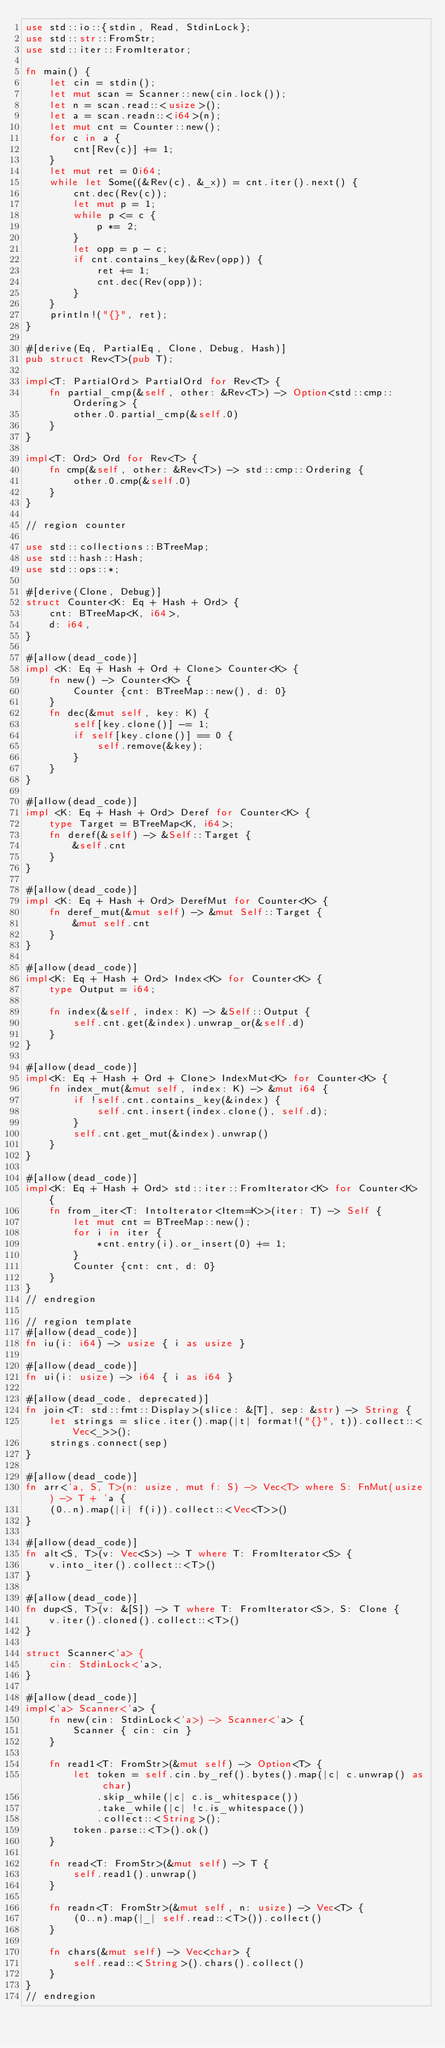Convert code to text. <code><loc_0><loc_0><loc_500><loc_500><_Rust_>use std::io::{stdin, Read, StdinLock};
use std::str::FromStr;
use std::iter::FromIterator;

fn main() {
    let cin = stdin();
    let mut scan = Scanner::new(cin.lock());
    let n = scan.read::<usize>();
    let a = scan.readn::<i64>(n);
    let mut cnt = Counter::new();
    for c in a {
        cnt[Rev(c)] += 1;
    }
    let mut ret = 0i64;
    while let Some((&Rev(c), &_x)) = cnt.iter().next() {
        cnt.dec(Rev(c));
        let mut p = 1;
        while p <= c {
            p *= 2;
        }
        let opp = p - c;
        if cnt.contains_key(&Rev(opp)) {
            ret += 1;
            cnt.dec(Rev(opp));
        }
    }
    println!("{}", ret);
}

#[derive(Eq, PartialEq, Clone, Debug, Hash)]
pub struct Rev<T>(pub T);

impl<T: PartialOrd> PartialOrd for Rev<T> {
    fn partial_cmp(&self, other: &Rev<T>) -> Option<std::cmp::Ordering> {
        other.0.partial_cmp(&self.0)
    }
}

impl<T: Ord> Ord for Rev<T> {
    fn cmp(&self, other: &Rev<T>) -> std::cmp::Ordering {
        other.0.cmp(&self.0)
    }
}

// region counter

use std::collections::BTreeMap;
use std::hash::Hash;
use std::ops::*;

#[derive(Clone, Debug)]
struct Counter<K: Eq + Hash + Ord> {
    cnt: BTreeMap<K, i64>,
    d: i64,
}

#[allow(dead_code)]
impl <K: Eq + Hash + Ord + Clone> Counter<K> {
    fn new() -> Counter<K> {
        Counter {cnt: BTreeMap::new(), d: 0}
    }
    fn dec(&mut self, key: K) {
        self[key.clone()] -= 1;
        if self[key.clone()] == 0 {
            self.remove(&key);
        }
    }
}

#[allow(dead_code)]
impl <K: Eq + Hash + Ord> Deref for Counter<K> {
    type Target = BTreeMap<K, i64>;
    fn deref(&self) -> &Self::Target {
        &self.cnt
    }
}

#[allow(dead_code)]
impl <K: Eq + Hash + Ord> DerefMut for Counter<K> {
    fn deref_mut(&mut self) -> &mut Self::Target {
        &mut self.cnt
    }
}

#[allow(dead_code)]
impl<K: Eq + Hash + Ord> Index<K> for Counter<K> {
    type Output = i64;

    fn index(&self, index: K) -> &Self::Output {
        self.cnt.get(&index).unwrap_or(&self.d)
    }
}

#[allow(dead_code)]
impl<K: Eq + Hash + Ord + Clone> IndexMut<K> for Counter<K> {
    fn index_mut(&mut self, index: K) -> &mut i64 {
        if !self.cnt.contains_key(&index) {
            self.cnt.insert(index.clone(), self.d);
        }
        self.cnt.get_mut(&index).unwrap()
    }
}

#[allow(dead_code)]
impl<K: Eq + Hash + Ord> std::iter::FromIterator<K> for Counter<K> {
    fn from_iter<T: IntoIterator<Item=K>>(iter: T) -> Self {
        let mut cnt = BTreeMap::new();
        for i in iter {
            *cnt.entry(i).or_insert(0) += 1;
        }
        Counter {cnt: cnt, d: 0}
    }
}
// endregion

// region template
#[allow(dead_code)]
fn iu(i: i64) -> usize { i as usize }

#[allow(dead_code)]
fn ui(i: usize) -> i64 { i as i64 }

#[allow(dead_code, deprecated)]
fn join<T: std::fmt::Display>(slice: &[T], sep: &str) -> String {
    let strings = slice.iter().map(|t| format!("{}", t)).collect::<Vec<_>>();
    strings.connect(sep)
}

#[allow(dead_code)]
fn arr<'a, S, T>(n: usize, mut f: S) -> Vec<T> where S: FnMut(usize) -> T + 'a {
    (0..n).map(|i| f(i)).collect::<Vec<T>>()
}

#[allow(dead_code)]
fn alt<S, T>(v: Vec<S>) -> T where T: FromIterator<S> {
    v.into_iter().collect::<T>()
}

#[allow(dead_code)]
fn dup<S, T>(v: &[S]) -> T where T: FromIterator<S>, S: Clone {
    v.iter().cloned().collect::<T>()
}

struct Scanner<'a> {
    cin: StdinLock<'a>,
}

#[allow(dead_code)]
impl<'a> Scanner<'a> {
    fn new(cin: StdinLock<'a>) -> Scanner<'a> {
        Scanner { cin: cin }
    }

    fn read1<T: FromStr>(&mut self) -> Option<T> {
        let token = self.cin.by_ref().bytes().map(|c| c.unwrap() as char)
            .skip_while(|c| c.is_whitespace())
            .take_while(|c| !c.is_whitespace())
            .collect::<String>();
        token.parse::<T>().ok()
    }

    fn read<T: FromStr>(&mut self) -> T {
        self.read1().unwrap()
    }

    fn readn<T: FromStr>(&mut self, n: usize) -> Vec<T> {
        (0..n).map(|_| self.read::<T>()).collect()
    }

    fn chars(&mut self) -> Vec<char> {
        self.read::<String>().chars().collect()
    }
}
// endregion</code> 